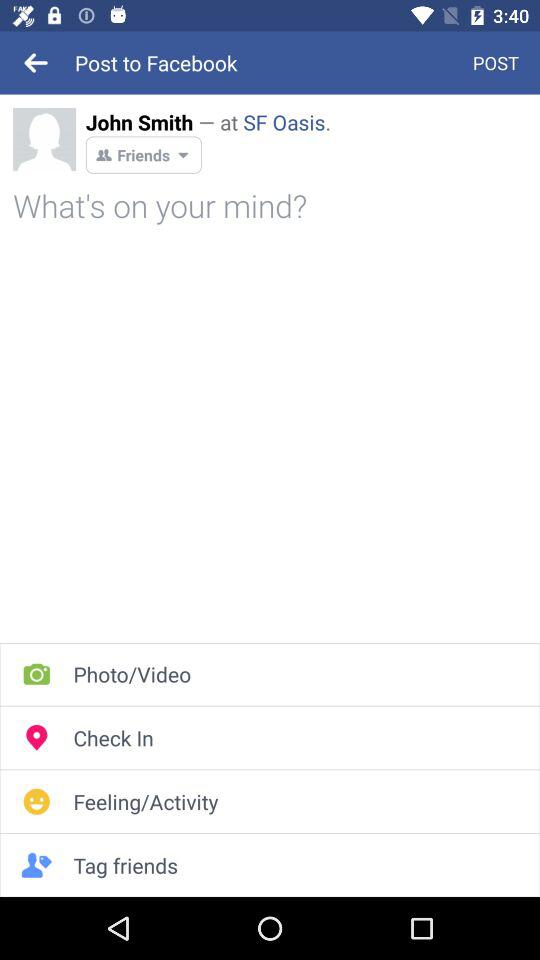What is the location? The location is the SF Oasis. 